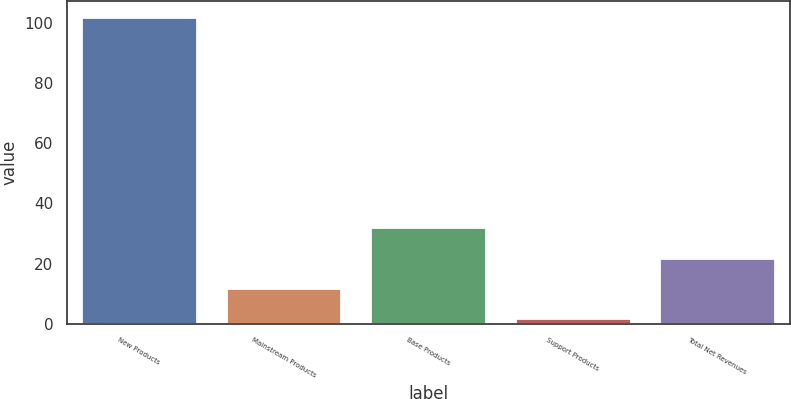<chart> <loc_0><loc_0><loc_500><loc_500><bar_chart><fcel>New Products<fcel>Mainstream Products<fcel>Base Products<fcel>Support Products<fcel>Total Net Revenues<nl><fcel>102<fcel>12<fcel>32<fcel>2<fcel>22<nl></chart> 